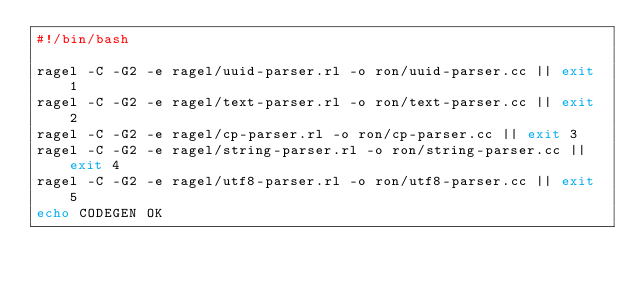<code> <loc_0><loc_0><loc_500><loc_500><_Bash_>#!/bin/bash

ragel -C -G2 -e ragel/uuid-parser.rl -o ron/uuid-parser.cc || exit 1
ragel -C -G2 -e ragel/text-parser.rl -o ron/text-parser.cc || exit 2
ragel -C -G2 -e ragel/cp-parser.rl -o ron/cp-parser.cc || exit 3
ragel -C -G2 -e ragel/string-parser.rl -o ron/string-parser.cc || exit 4
ragel -C -G2 -e ragel/utf8-parser.rl -o ron/utf8-parser.cc || exit 5
echo CODEGEN OK
</code> 